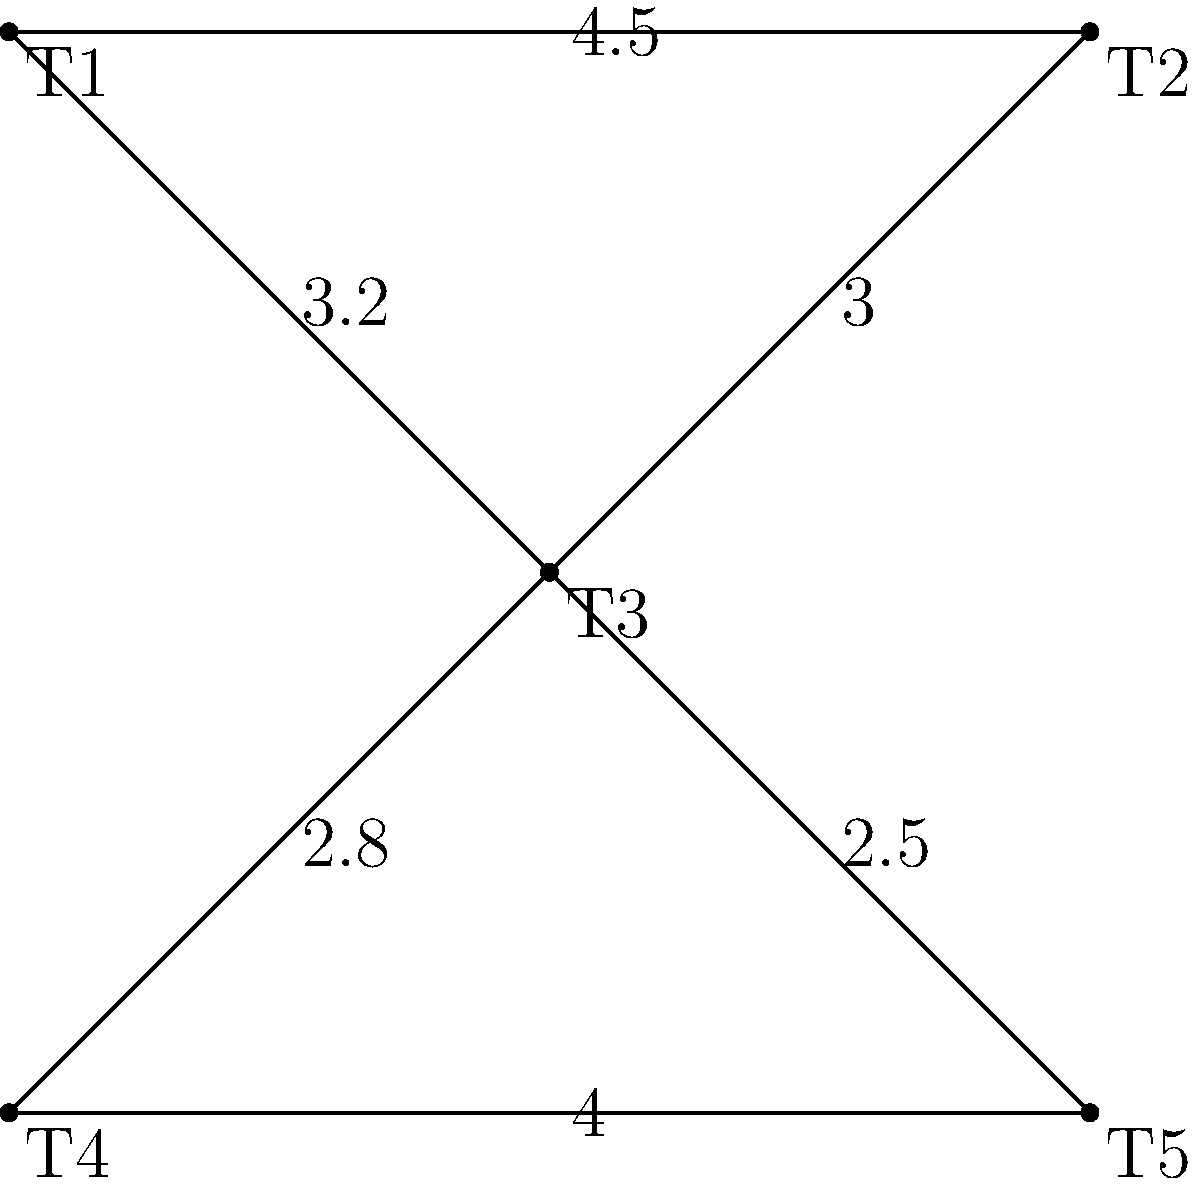In your café, you've mapped out the paths between tables as a weighted graph, where the weights represent the time (in seconds) it takes for a server to move between tables. Given the graph above, what is the minimum time required for a server to visit all tables exactly once, starting and ending at table T1? To solve this problem, we need to find the shortest Hamiltonian cycle in the graph, also known as the Traveling Salesman Problem (TSP). Here's a step-by-step approach:

1) First, list all possible Hamiltonian cycles starting and ending at T1:
   - T1 → T2 → T3 → T4 → T5 → T1
   - T1 → T2 → T3 → T5 → T4 → T1
   - T1 → T3 → T2 → T4 → T5 → T1
   - T1 → T3 → T4 → T5 → T2 → T1
   - T1 → T3 → T5 → T4 → T2 → T1

2) Calculate the total time for each cycle:
   - T1 → T2 → T3 → T4 → T5 → T1 = 4.5 + 3.0 + 2.8 + 4.0 + 4.5 = 18.8s
   - T1 → T2 → T3 → T5 → T4 → T1 = 4.5 + 3.0 + 2.5 + 4.0 + 4.5 = 18.5s
   - T1 → T3 → T2 → T4 → T5 → T1 = 3.2 + 3.0 + 2.8 + 4.0 + 4.5 = 17.5s
   - T1 → T3 → T4 → T5 → T2 → T1 = 3.2 + 2.8 + 4.0 + 4.5 + 4.5 = 19.0s
   - T1 → T3 → T5 → T4 → T2 → T1 = 3.2 + 2.5 + 4.0 + 4.5 + 4.5 = 18.7s

3) The minimum time is achieved by the path T1 → T3 → T2 → T4 → T5 → T1, which takes 17.5 seconds.
Answer: 17.5 seconds 